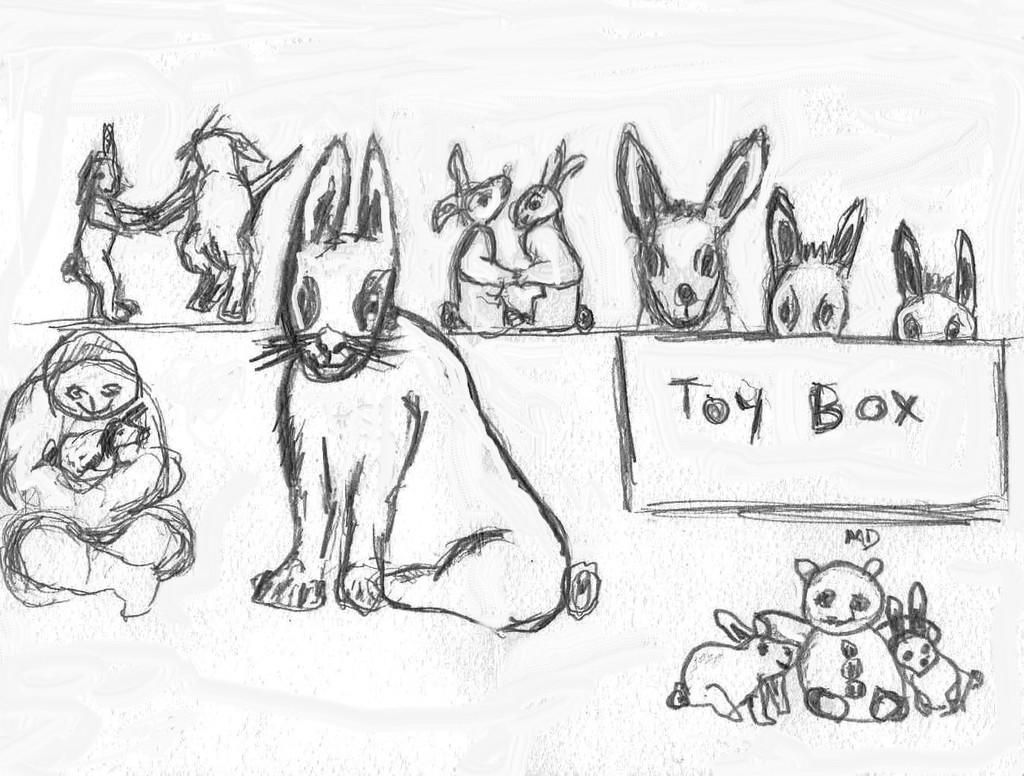What type of art is featured in the image? There is pencil art in the image. What subject matter is depicted in the art? The art depicts rabbits. On what surface is the art created? The art is on a paper. What shape is the cow in the image? There is no cow present in the image; it features pencil art of rabbits. Are the rabbits fighting in the image? The image does not depict any fighting or conflict between the rabbits. 